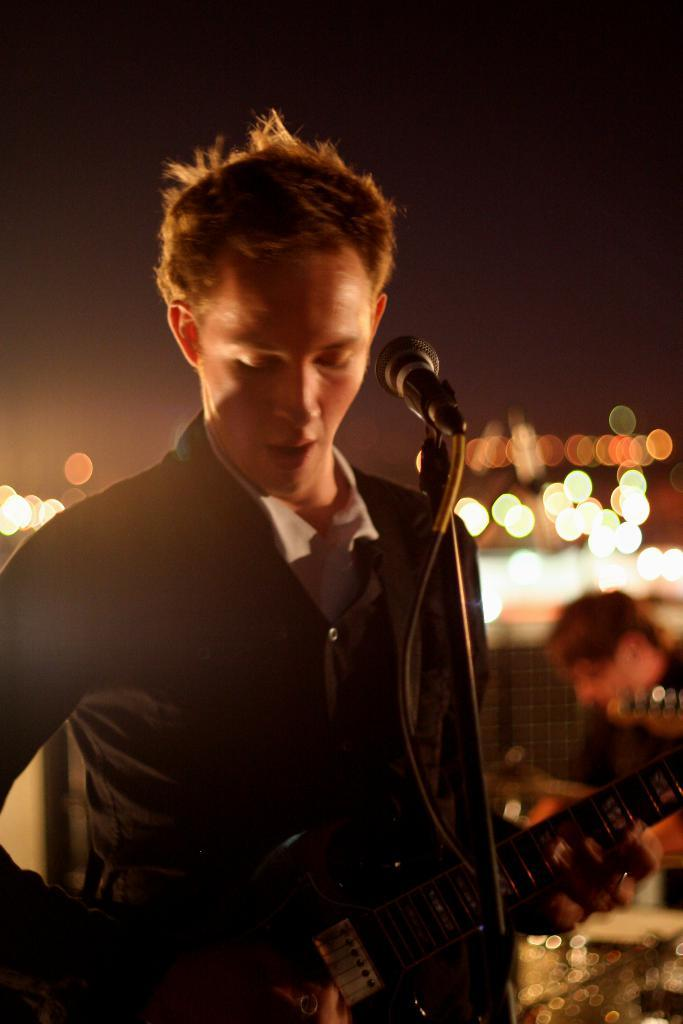Who is the person in the image? There is a man in the image. What is the man doing in the image? The man is playing a guitar. What other object is present in the image related to the man's activity? There is a microphone (mike) in the image. What can be seen in the background that might indicate the setting? There are lights visible in the image. How does the man twist the guitar strings in the image? The man is not twisting the guitar strings in the image; he is playing the guitar. 